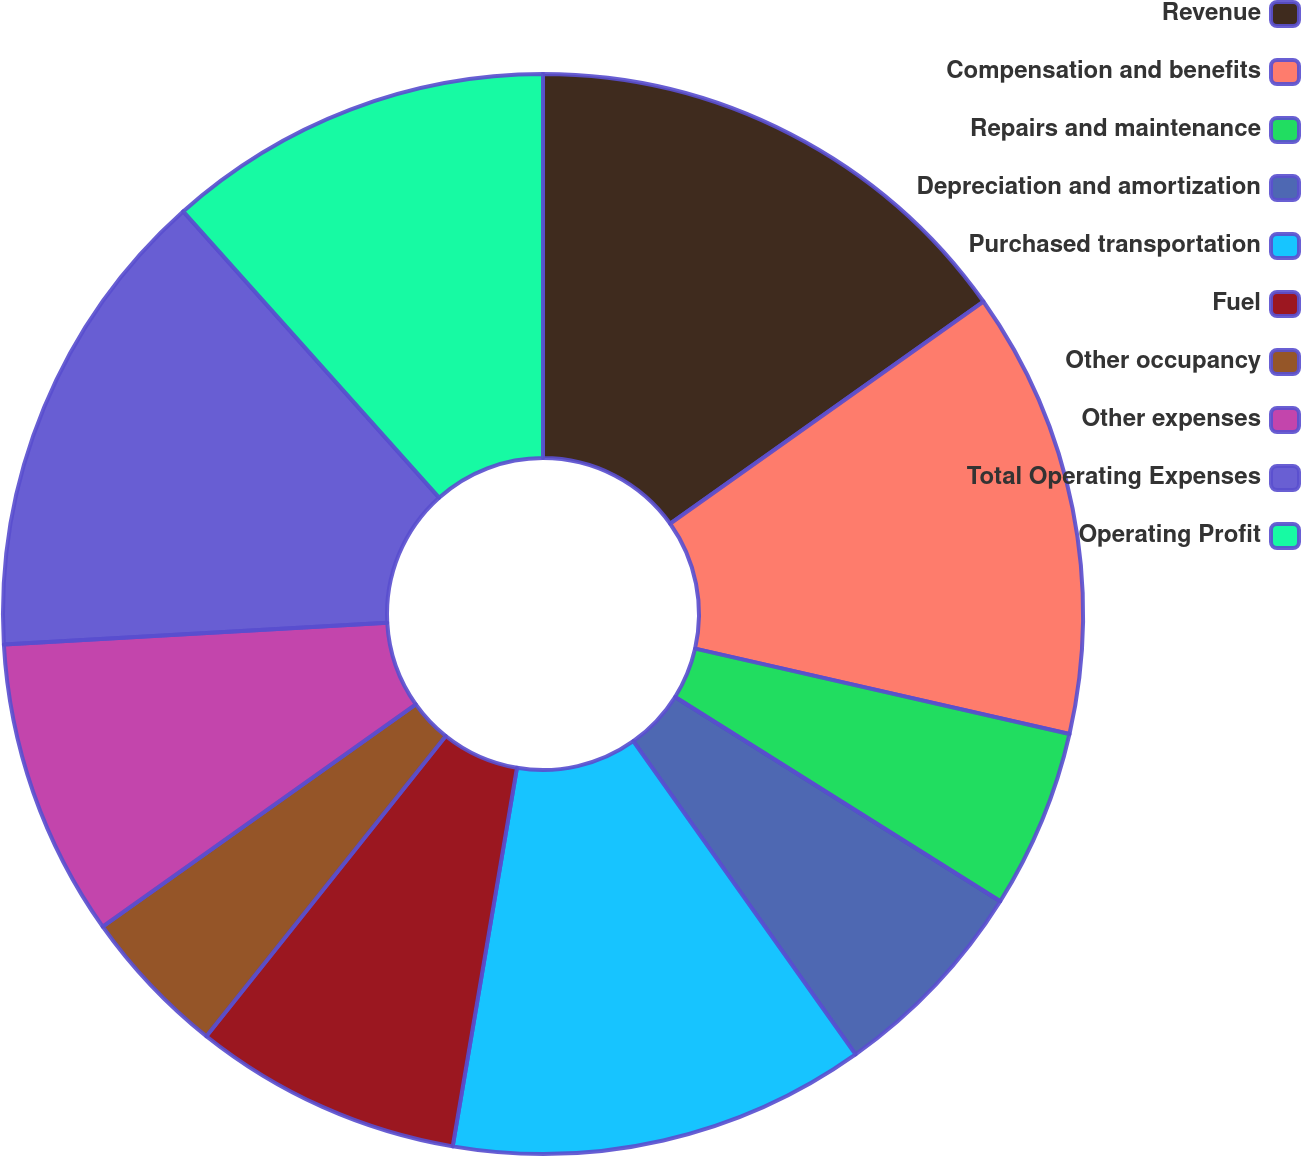<chart> <loc_0><loc_0><loc_500><loc_500><pie_chart><fcel>Revenue<fcel>Compensation and benefits<fcel>Repairs and maintenance<fcel>Depreciation and amortization<fcel>Purchased transportation<fcel>Fuel<fcel>Other occupancy<fcel>Other expenses<fcel>Total Operating Expenses<fcel>Operating Profit<nl><fcel>15.18%<fcel>13.39%<fcel>5.36%<fcel>6.25%<fcel>12.5%<fcel>8.04%<fcel>4.46%<fcel>8.93%<fcel>14.29%<fcel>11.61%<nl></chart> 